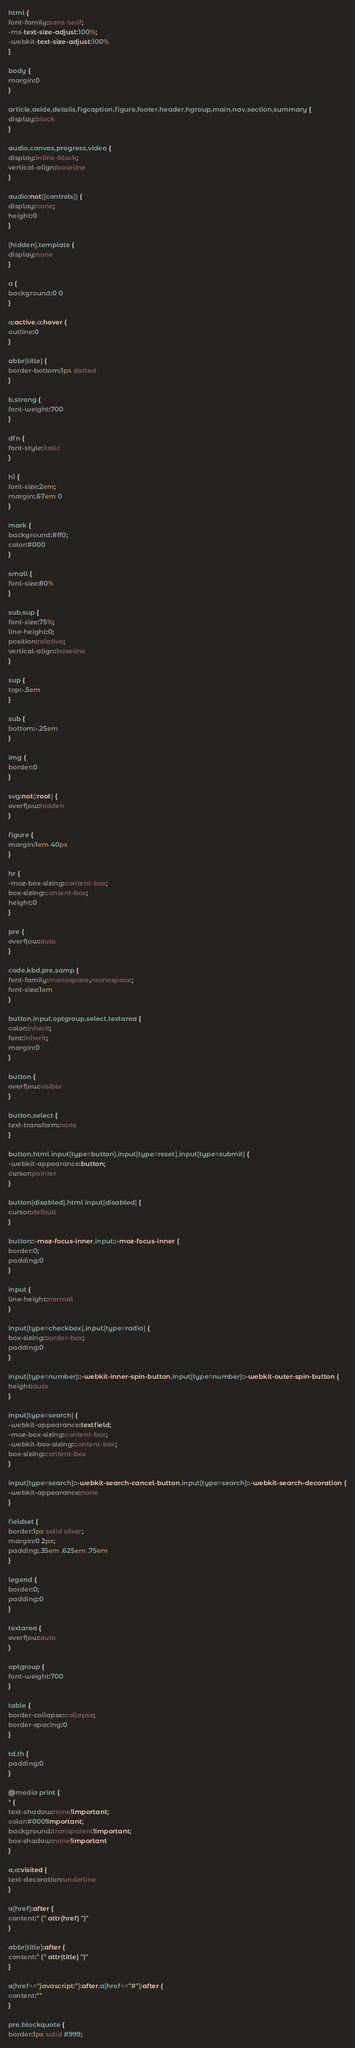Convert code to text. <code><loc_0><loc_0><loc_500><loc_500><_CSS_>html {
font-family:sans-serif;
-ms-text-size-adjust:100%;
-webkit-text-size-adjust:100%
}

body {
margin:0
}

article,aside,details,figcaption,figure,footer,header,hgroup,main,nav,section,summary {
display:block
}

audio,canvas,progress,video {
display:inline-block;
vertical-align:baseline
}

audio:not([controls]) {
display:none;
height:0
}

[hidden],template {
display:none
}

a {
background:0 0
}

a:active,a:hover {
outline:0
}

abbr[title] {
border-bottom:1px dotted
}

b,strong {
font-weight:700
}

dfn {
font-style:italic
}

h1 {
font-size:2em;
margin:.67em 0
}

mark {
background:#ff0;
color:#000
}

small {
font-size:80%
}

sub,sup {
font-size:75%;
line-height:0;
position:relative;
vertical-align:baseline
}

sup {
top:-.5em
}

sub {
bottom:-.25em
}

img {
border:0
}

svg:not(:root) {
overflow:hidden
}

figure {
margin:1em 40px
}

hr {
-moz-box-sizing:content-box;
box-sizing:content-box;
height:0
}

pre {
overflow:auto
}

code,kbd,pre,samp {
font-family:monospace,monospace;
font-size:1em
}

button,input,optgroup,select,textarea {
color:inherit;
font:inherit;
margin:0
}

button {
overflow:visible
}

button,select {
text-transform:none
}

button,html input[type=button],input[type=reset],input[type=submit] {
-webkit-appearance:button;
cursor:pointer
}

button[disabled],html input[disabled] {
cursor:default
}

button::-moz-focus-inner,input::-moz-focus-inner {
border:0;
padding:0
}

input {
line-height:normal
}

input[type=checkbox],input[type=radio] {
box-sizing:border-box;
padding:0
}

input[type=number]::-webkit-inner-spin-button,input[type=number]::-webkit-outer-spin-button {
height:auto
}

input[type=search] {
-webkit-appearance:textfield;
-moz-box-sizing:content-box;
-webkit-box-sizing:content-box;
box-sizing:content-box
}

input[type=search]::-webkit-search-cancel-button,input[type=search]::-webkit-search-decoration {
-webkit-appearance:none
}

fieldset {
border:1px solid silver;
margin:0 2px;
padding:.35em .625em .75em
}

legend {
border:0;
padding:0
}

textarea {
overflow:auto
}

optgroup {
font-weight:700
}

table {
border-collapse:collapse;
border-spacing:0
}

td,th {
padding:0
}

@media print {
* {
text-shadow:none!important;
color:#000!important;
background:transparent!important;
box-shadow:none!important
}

a,a:visited {
text-decoration:underline
}

a[href]:after {
content:" (" attr(href) ")"
}

abbr[title]:after {
content:" (" attr(title) ")"
}

a[href^="javascript:"]:after,a[href^="#"]:after {
content:""
}

pre,blockquote {
border:1px solid #999;</code> 